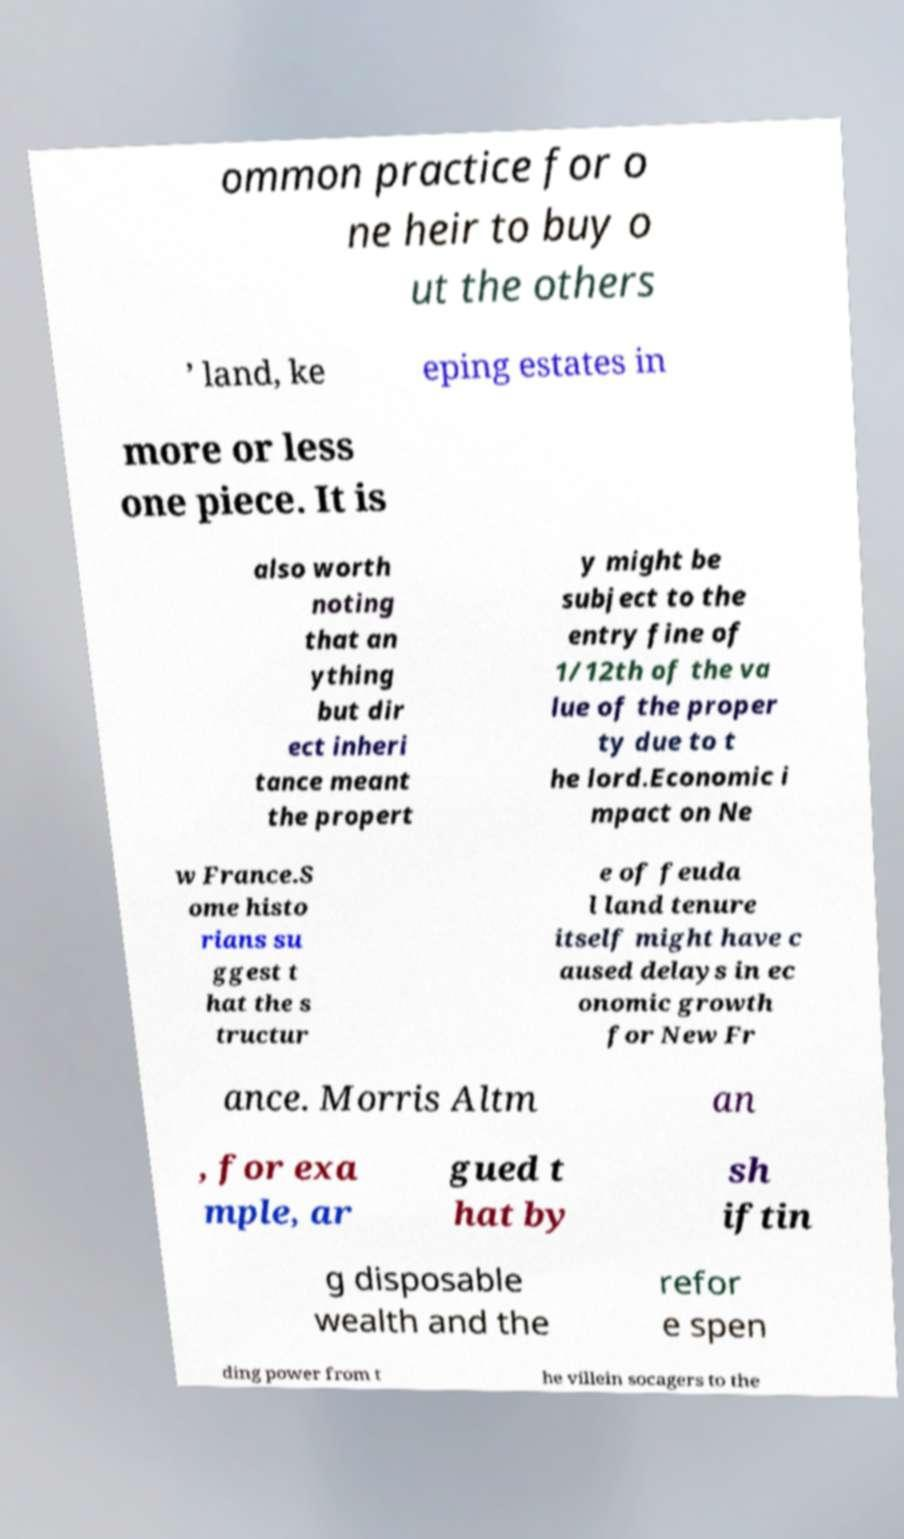Please read and relay the text visible in this image. What does it say? ommon practice for o ne heir to buy o ut the others ’ land, ke eping estates in more or less one piece. It is also worth noting that an ything but dir ect inheri tance meant the propert y might be subject to the entry fine of 1/12th of the va lue of the proper ty due to t he lord.Economic i mpact on Ne w France.S ome histo rians su ggest t hat the s tructur e of feuda l land tenure itself might have c aused delays in ec onomic growth for New Fr ance. Morris Altm an , for exa mple, ar gued t hat by sh iftin g disposable wealth and the refor e spen ding power from t he villein socagers to the 